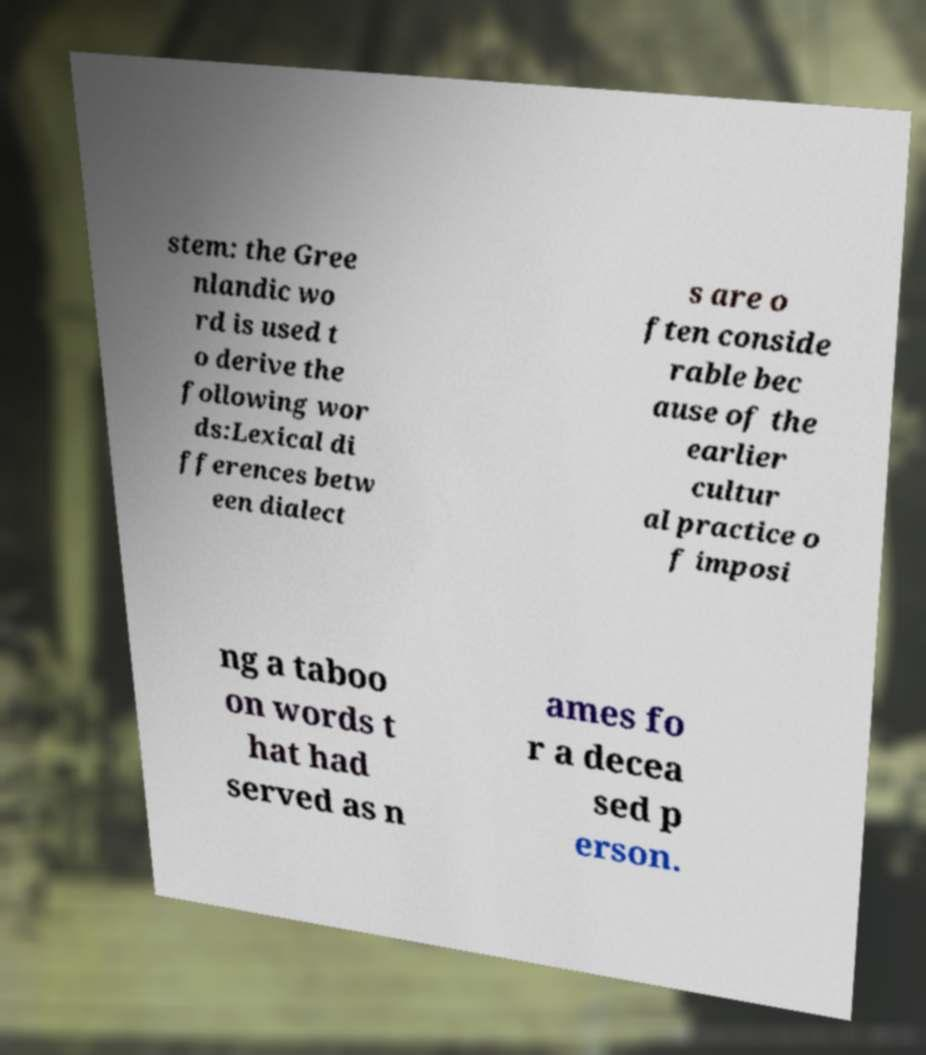Can you accurately transcribe the text from the provided image for me? stem: the Gree nlandic wo rd is used t o derive the following wor ds:Lexical di fferences betw een dialect s are o ften conside rable bec ause of the earlier cultur al practice o f imposi ng a taboo on words t hat had served as n ames fo r a decea sed p erson. 